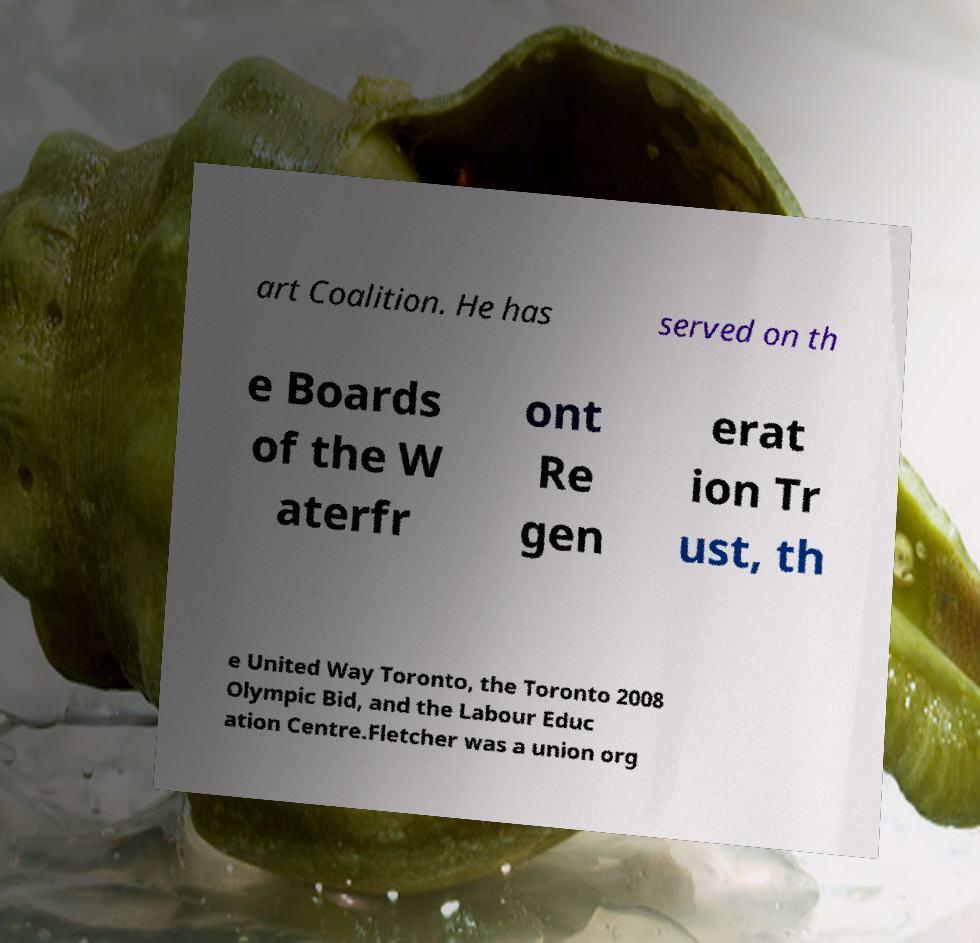I need the written content from this picture converted into text. Can you do that? art Coalition. He has served on th e Boards of the W aterfr ont Re gen erat ion Tr ust, th e United Way Toronto, the Toronto 2008 Olympic Bid, and the Labour Educ ation Centre.Fletcher was a union org 